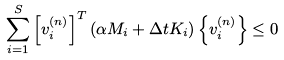<formula> <loc_0><loc_0><loc_500><loc_500>\sum _ { i = 1 } ^ { S } \left [ v _ { i } ^ { ( n ) } \right ] ^ { T } \left ( \alpha M _ { i } + \Delta t K _ { i } \right ) \left \{ v _ { i } ^ { ( n ) } \right \} \leq 0</formula> 